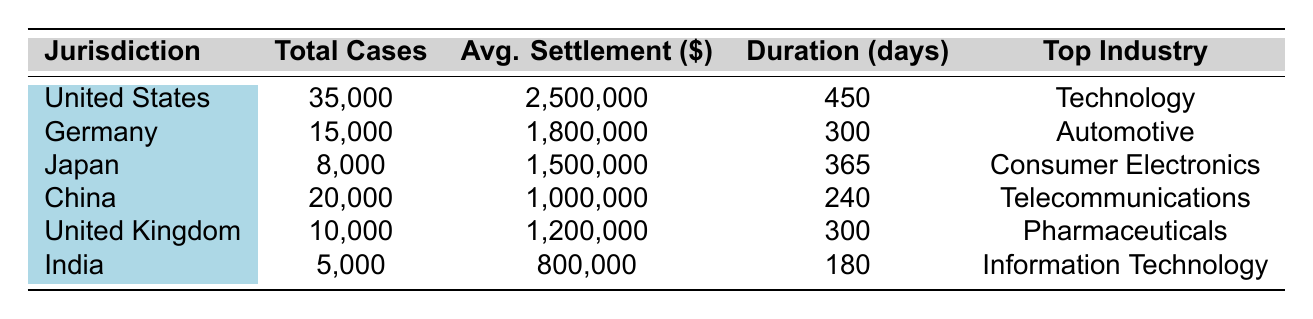What is the total number of patent litigation cases in the United States? The table shows that the total cases for the United States jurisdiction is listed directly as 35,000.
Answer: 35,000 Which country has the highest average settlement amount? By comparing the average settlement values listed, the United States has the highest average settlement at 2,500,000.
Answer: United States How many cases were resolved in Germany? The table indicates that the number of resolved cases in Germany is 12,000.
Answer: 12,000 What is the average case duration in India compared to China? India has a case duration of 180 days and China has 240 days. The difference is calculated as 240 - 180 = 60 days, indicating that China's cases last longer on average.
Answer: 60 days Which jurisdiction has the least number of patent litigation cases? By examining the total cases across jurisdictions, India has the least number at 5,000.
Answer: India What is the total number of resolved cases across all listed jurisdictions? The resolved cases for each jurisdiction add up as follows: 28,000 (US) + 12,000 (Germany) + 6,000 (Japan) + 16,000 (China) + 8,500 (UK) + 4,000 (India) = 74,500.
Answer: 74,500 Is the top industry in the United Kingdom Pharmaceuticals? According to the table, the top industry listed for the United Kingdom is indeed Pharmaceuticals, confirming the statement to be true.
Answer: Yes What is the difference in average settlement between the United States and India? The average settlements are 2,500,000 (US) and 800,000 (India). The difference is calculated as 2,500,000 - 800,000 = 1,700,000.
Answer: 1,700,000 How many total cases are reported in Europe (Germany and the United Kingdom)? Adding the total cases in Germany (15,000) and the United Kingdom (10,000) gives a total of 15,000 + 10,000 = 25,000.
Answer: 25,000 Which jurisdiction's notable case involved Qualcomm Inc.? The table states that the notable case in Germany involves Qualcomm Inc. versus Apple Inc.
Answer: Germany 